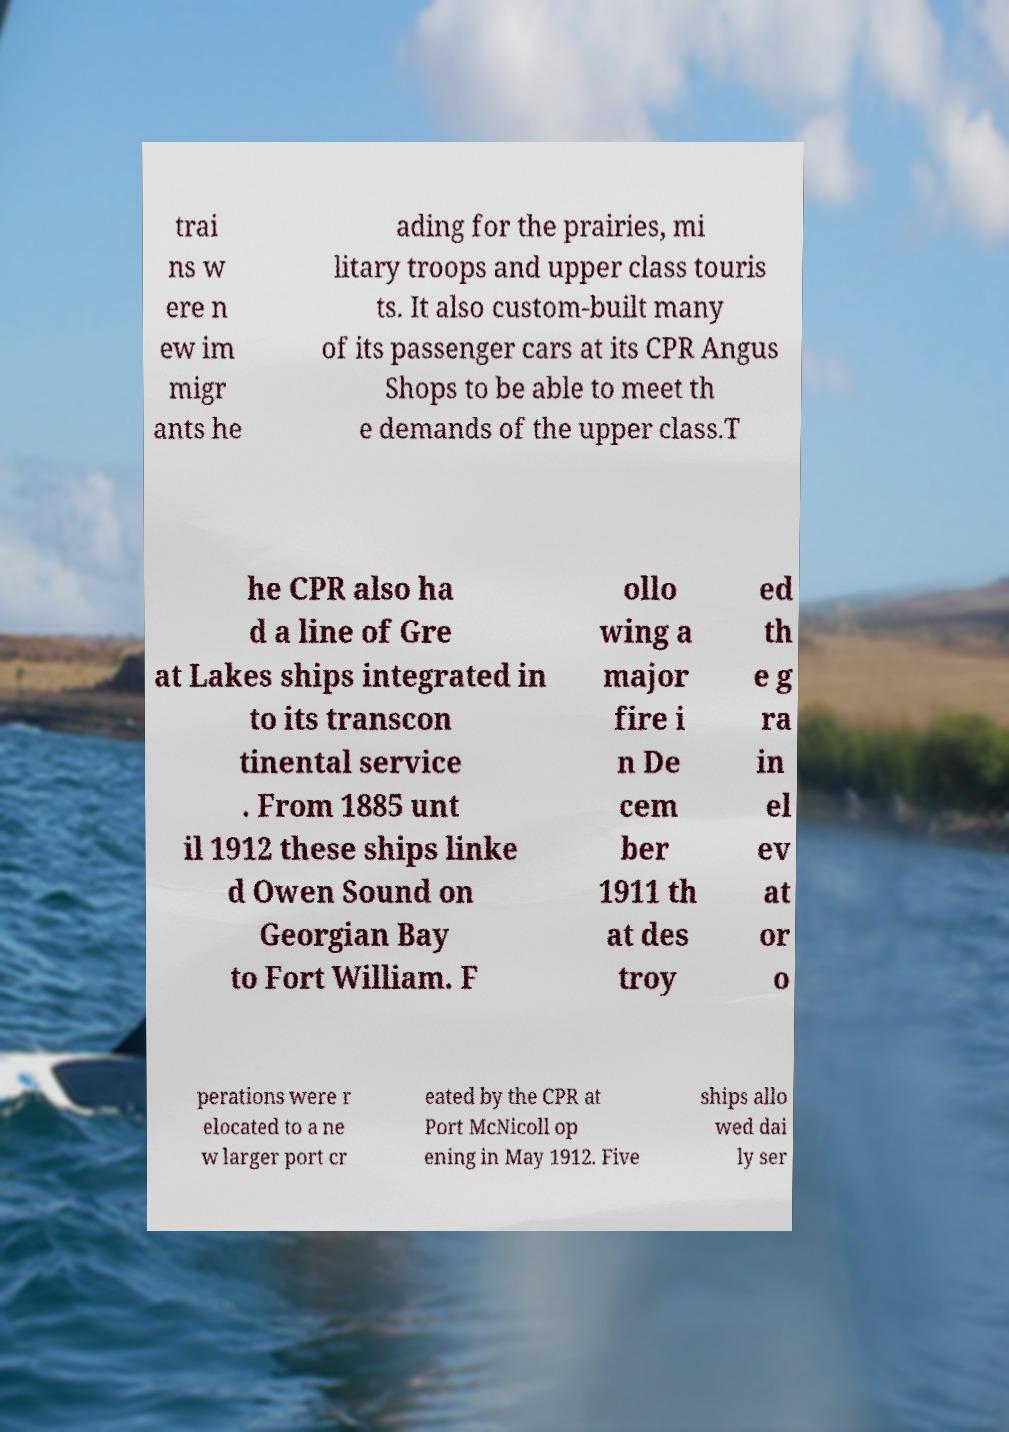Could you extract and type out the text from this image? trai ns w ere n ew im migr ants he ading for the prairies, mi litary troops and upper class touris ts. It also custom-built many of its passenger cars at its CPR Angus Shops to be able to meet th e demands of the upper class.T he CPR also ha d a line of Gre at Lakes ships integrated in to its transcon tinental service . From 1885 unt il 1912 these ships linke d Owen Sound on Georgian Bay to Fort William. F ollo wing a major fire i n De cem ber 1911 th at des troy ed th e g ra in el ev at or o perations were r elocated to a ne w larger port cr eated by the CPR at Port McNicoll op ening in May 1912. Five ships allo wed dai ly ser 